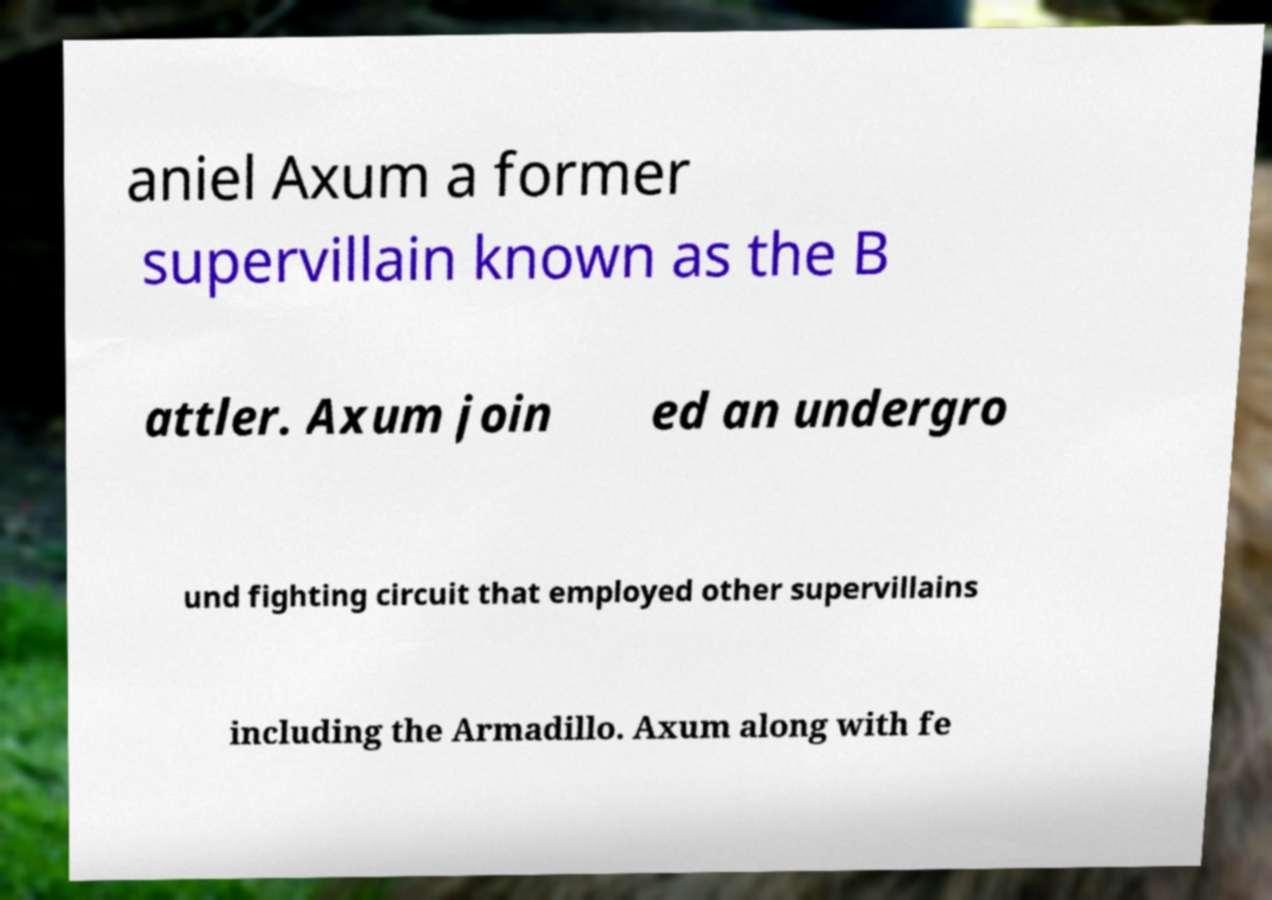Please identify and transcribe the text found in this image. aniel Axum a former supervillain known as the B attler. Axum join ed an undergro und fighting circuit that employed other supervillains including the Armadillo. Axum along with fe 